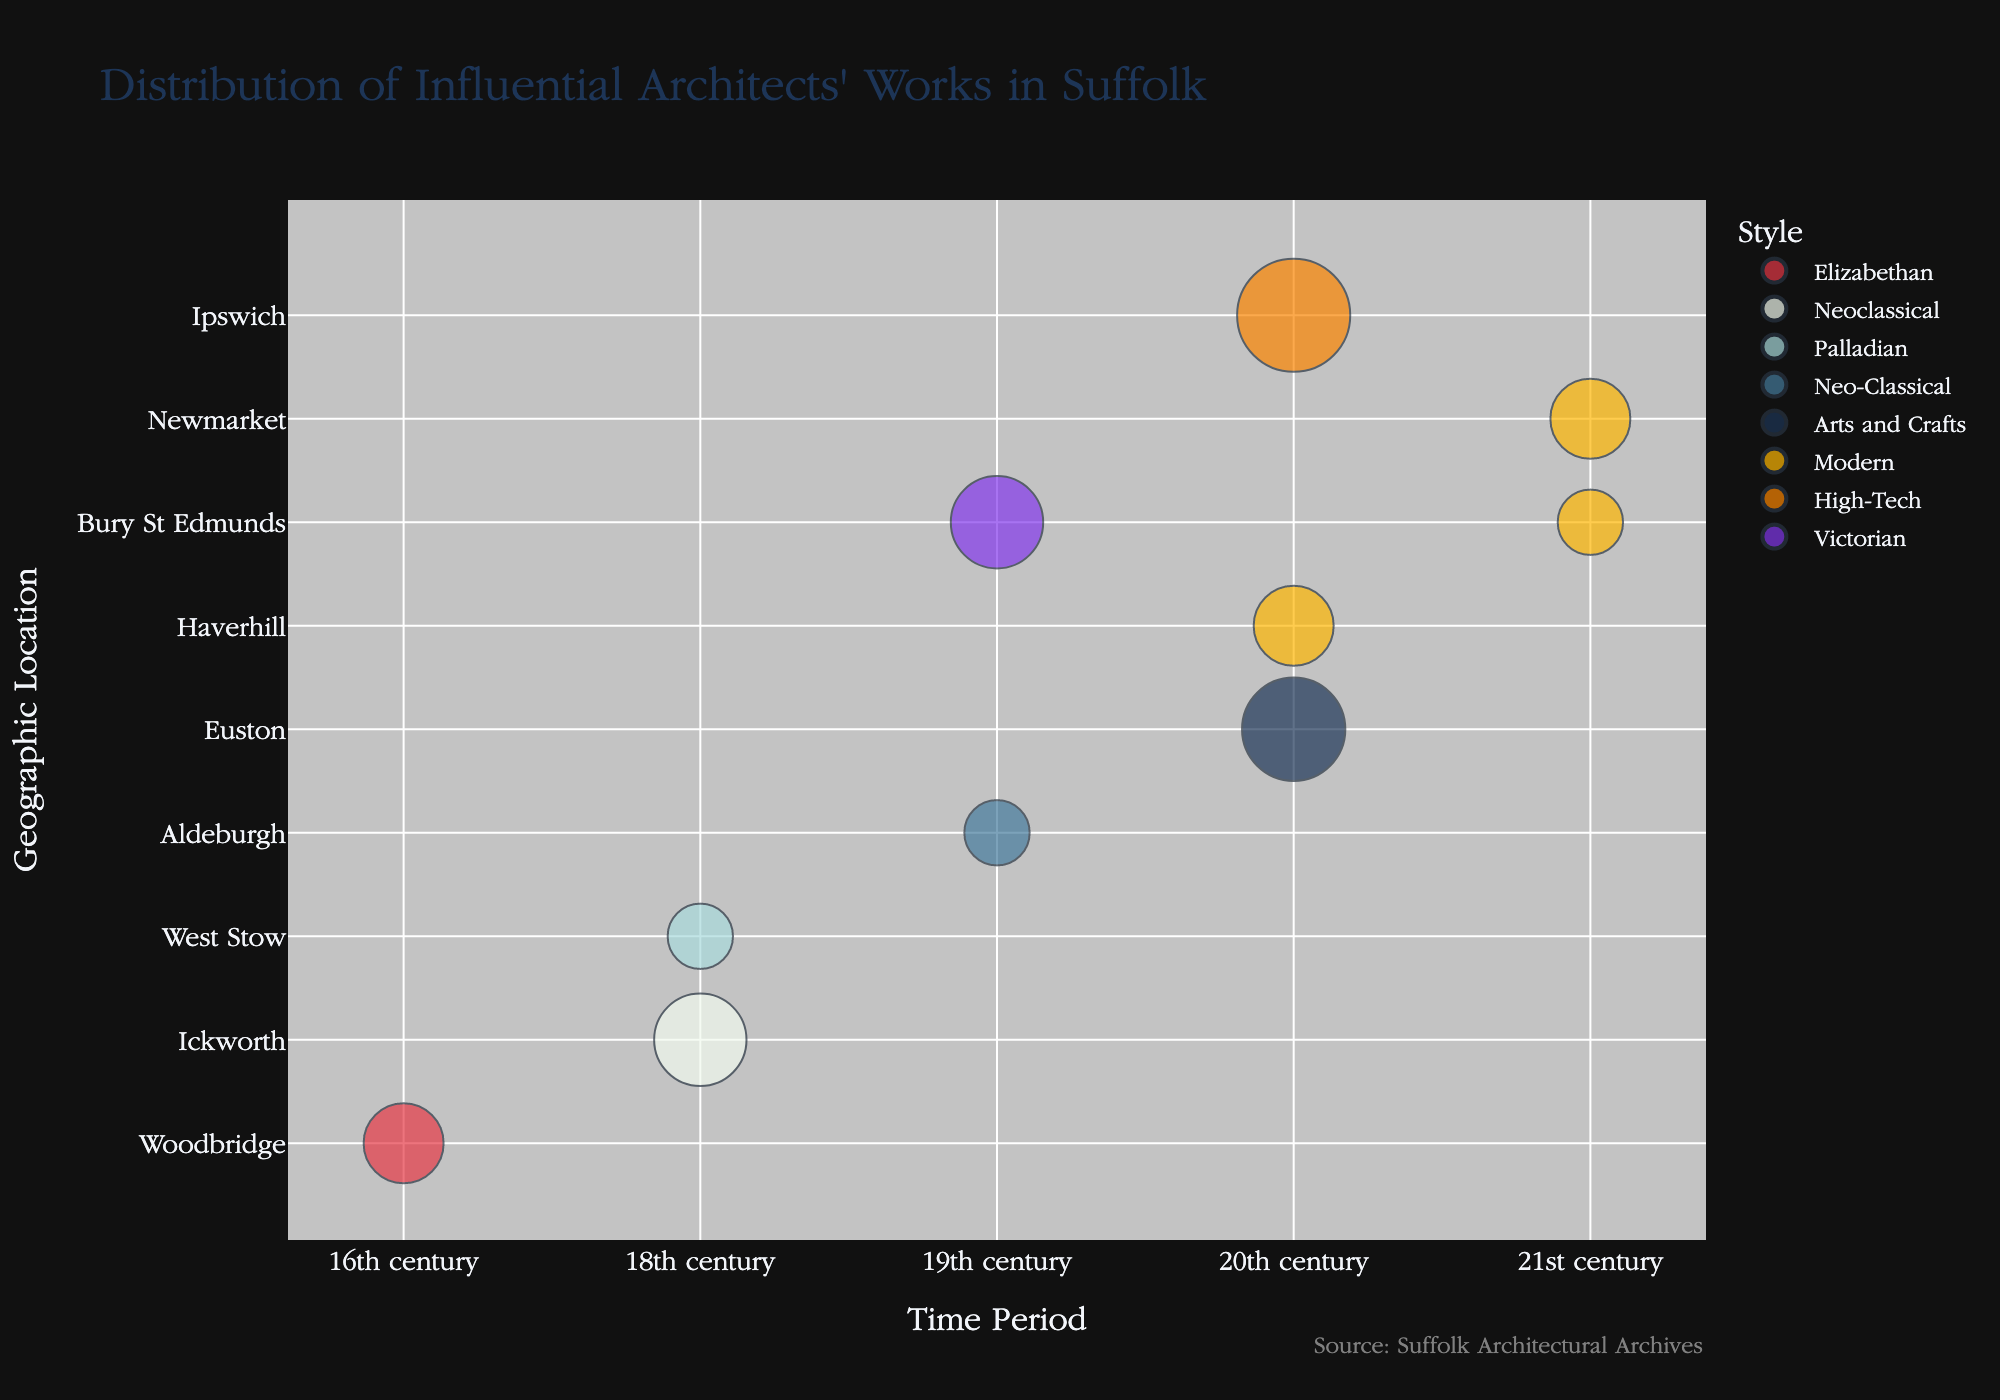Which time period has the highest count of influential architects' works? By observing the size of the bubbles, 20th century has the largest bubbles, indicating the highest count of works.
Answer: 20th century Which architect has the largest number of works listed? By looking at the bubble sizes and comparing, Norman Foster has the largest bubble, indicating he has the highest count.
Answer: Norman Foster What architectural styles are represented in the 18th century? By examining the bubbles in the 18th century row, two styles are represented: Neoclassical (Robert Adam) and Palladian (William Kent).
Answer: Neoclassical and Palladian How many works are attributed to architects in Bury St Edmunds from the 19th century onwards? There are two bubbles in Bury St Edmunds: one for the 19th century (George Skipper) with 4 works and one for the 21st century (Richard Rogers) with 2 works. Summing these gives 4 + 2 = 6.
Answer: 6 Compare the number of works by Edwin Lutyens and Michael Hopkins. Who has more? Edwin Lutyens has 5 works shown in the 20th century, and Michael Hopkins has 3 works in the 21st century. 5 is more than 3.
Answer: Edwin Lutyens What is the geographic location with the most styles represented? Bury St Edmunds has two styles: Victorian (19th century) and Modern (21st century). Other locations have a maximum of one style each.
Answer: Bury St Edmunds Which 21st-century architect has more works in Suffolk, Richard Rogers or Michael Hopkins? By comparing the bubble sizes, Richard Rogers has 2 works and Michael Hopkins has 3 works.
Answer: Michael Hopkins What styles are attributed to works in Ipswich, and which time period do they belong to? Ipswich has one bubble indicating the High-Tech style in the 20th century, represented by Norman Foster with 6 works.
Answer: High-Tech, 20th century Which geographic location hosts works from both the 19th and 21st centuries? Bury St Edmunds has bubbles for both the 19th century (George Skipper, Victorian) and the 21st century (Richard Rogers, Modern).
Answer: Bury St Edmunds 